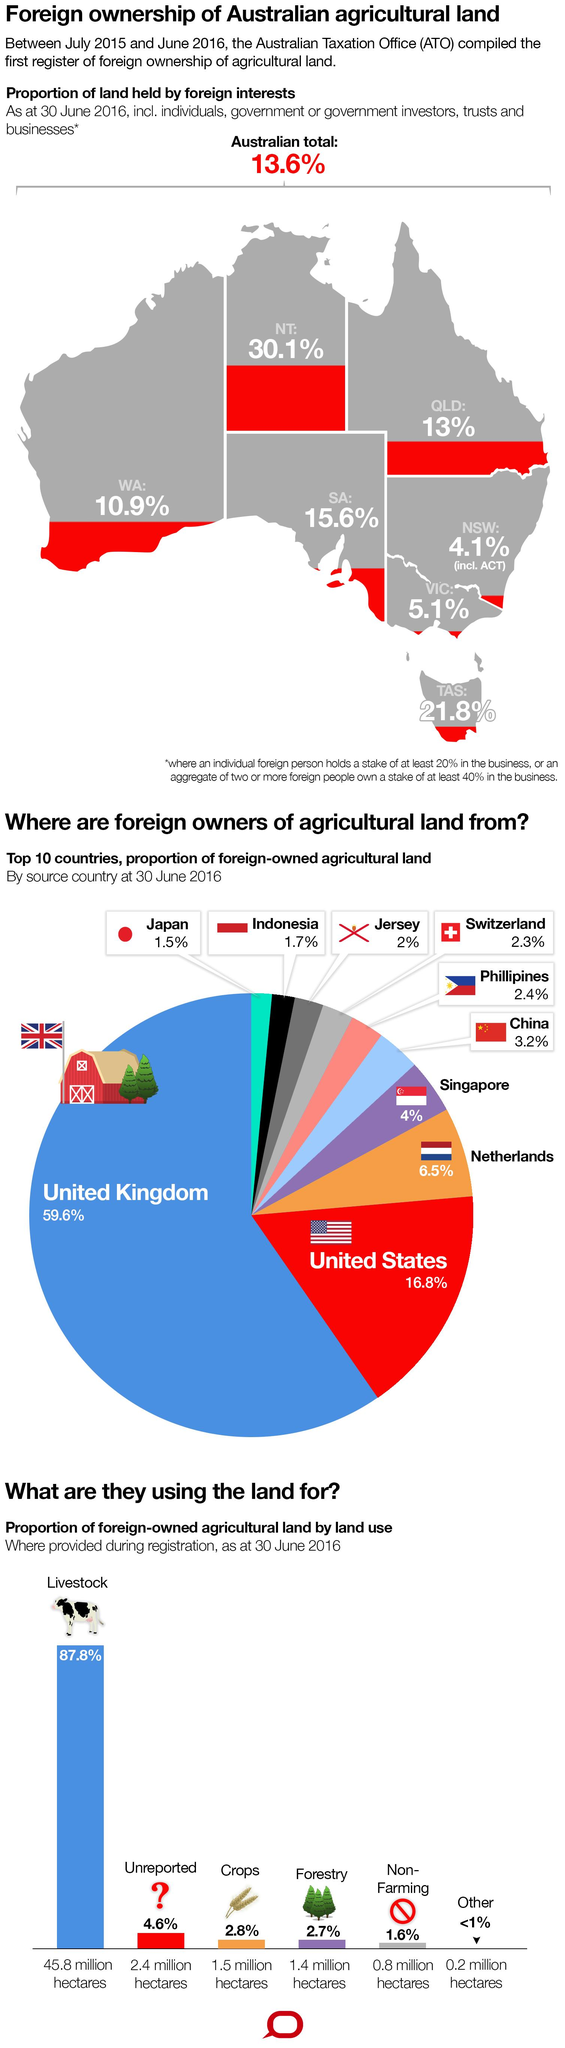Give some essential details in this illustration. It is estimated that a total of 90.6% of livestock and crops were taken together. The United States has the second-highest share of agricultural land among all countries. In total, livestock and forestry make up 90.5% of the land used in agriculture. The United Kingdom has the highest share of agricultural land among all countries, representing a significant portion of its total land area. 